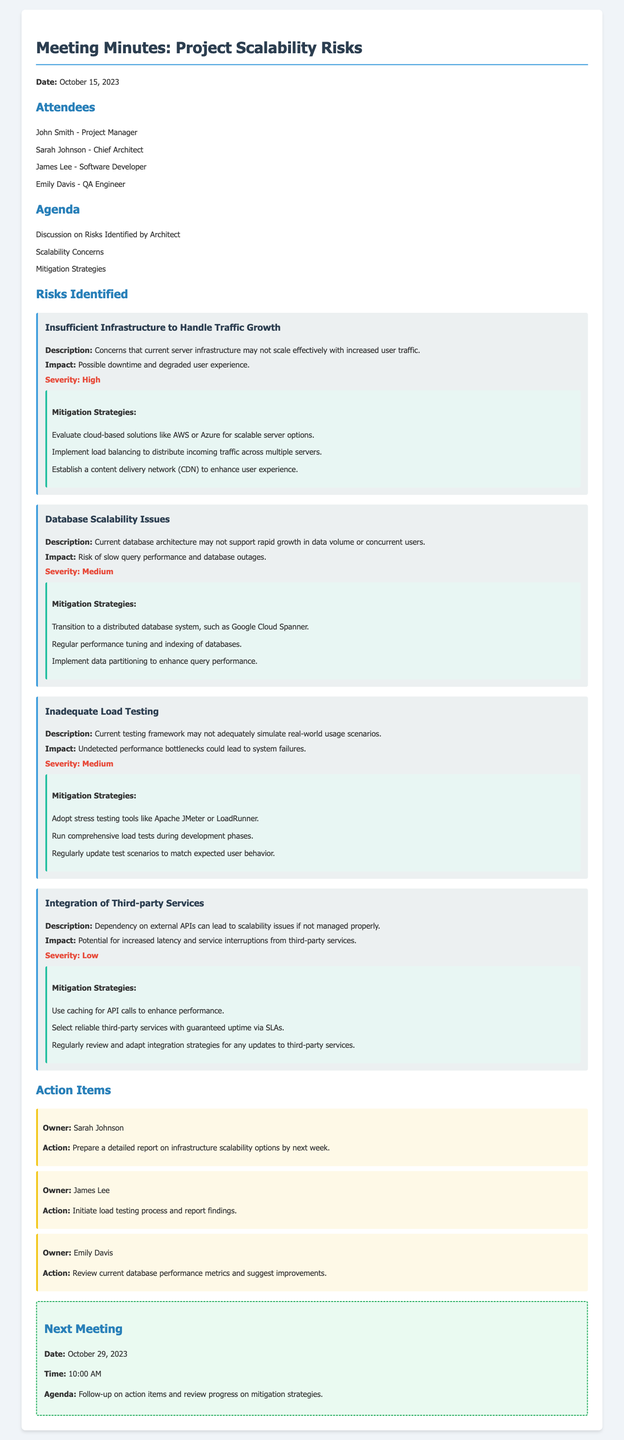What is the date of the meeting? The date of the meeting is stated in the document.
Answer: October 15, 2023 Who is the Chief Architect? The document lists attendees, including their roles.
Answer: Sarah Johnson What is the first risk identified by the architect? The first risk is outlined in the 'Risks Identified' section of the document.
Answer: Insufficient Infrastructure to Handle Traffic Growth What is the severity of Database Scalability Issues? The severity is specified alongside the description of each risk.
Answer: Medium What action is assigned to James Lee? The document lists action items with their respective owners and tasks.
Answer: Initiate load testing process and report findings How many risks were identified in total? The number of risks is indicated by the sections under 'Risks Identified.'
Answer: Four What is the next meeting date? The next meeting date is provided at the end of the document.
Answer: October 29, 2023 Which mitigation strategy is suggested for insufficient infrastructure? The document outlines several mitigation strategies for each risk.
Answer: Evaluate cloud-based solutions like AWS or Azure for scalable server options What is the primary concern regarding third-party services? The document highlights issues related to third-party services under its specific risk section.
Answer: Dependency on external APIs can lead to scalability issues if not managed properly What are the expected outcomes of the next meeting? The agenda for the next meeting indicates the expected discussion points.
Answer: Follow-up on action items and review progress on mitigation strategies 